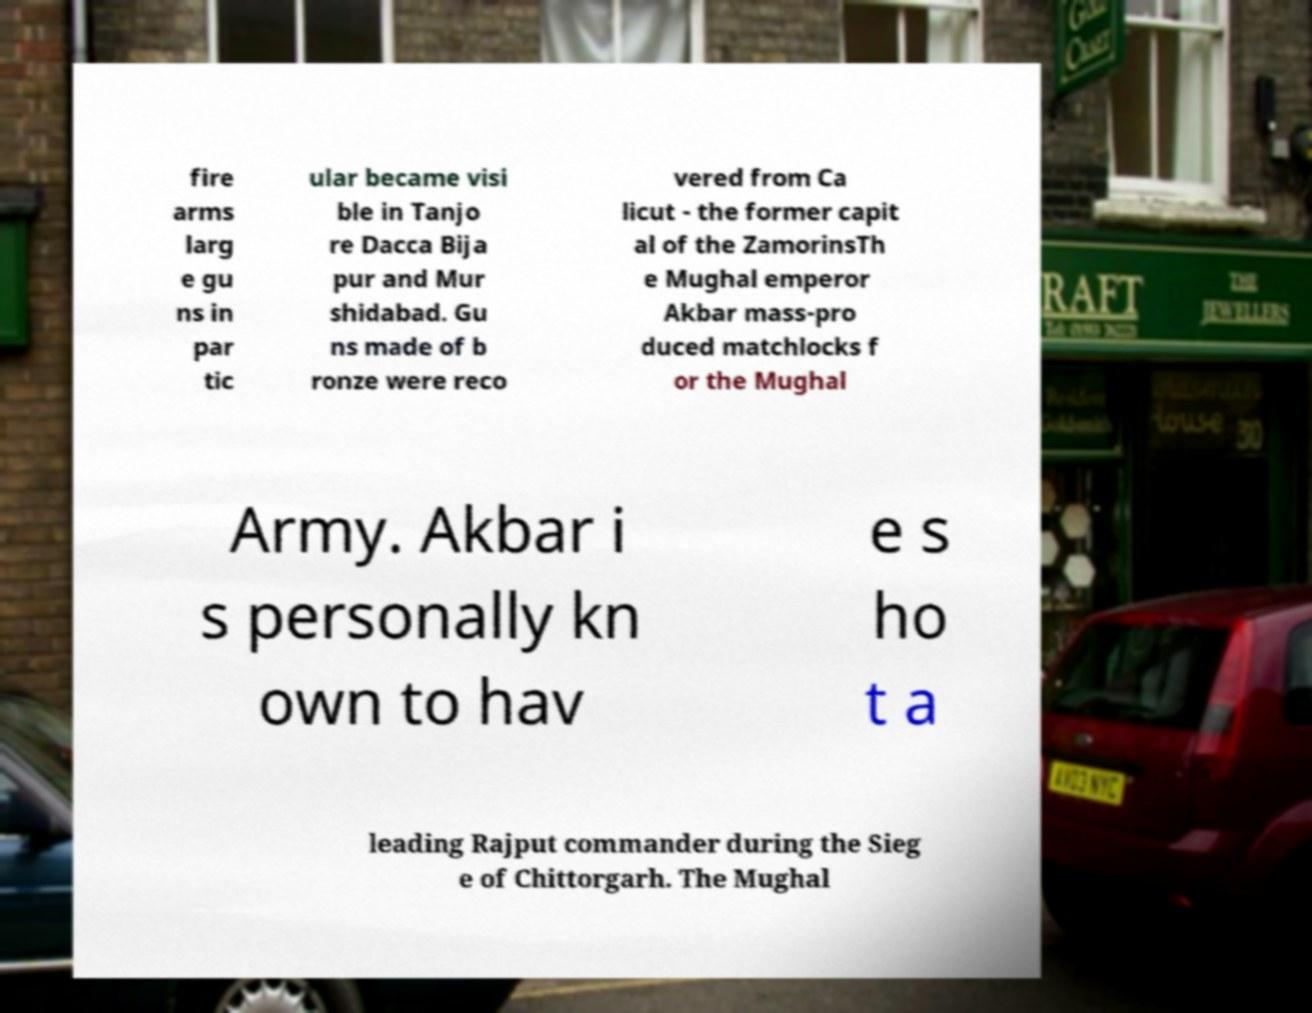Please read and relay the text visible in this image. What does it say? fire arms larg e gu ns in par tic ular became visi ble in Tanjo re Dacca Bija pur and Mur shidabad. Gu ns made of b ronze were reco vered from Ca licut - the former capit al of the ZamorinsTh e Mughal emperor Akbar mass-pro duced matchlocks f or the Mughal Army. Akbar i s personally kn own to hav e s ho t a leading Rajput commander during the Sieg e of Chittorgarh. The Mughal 